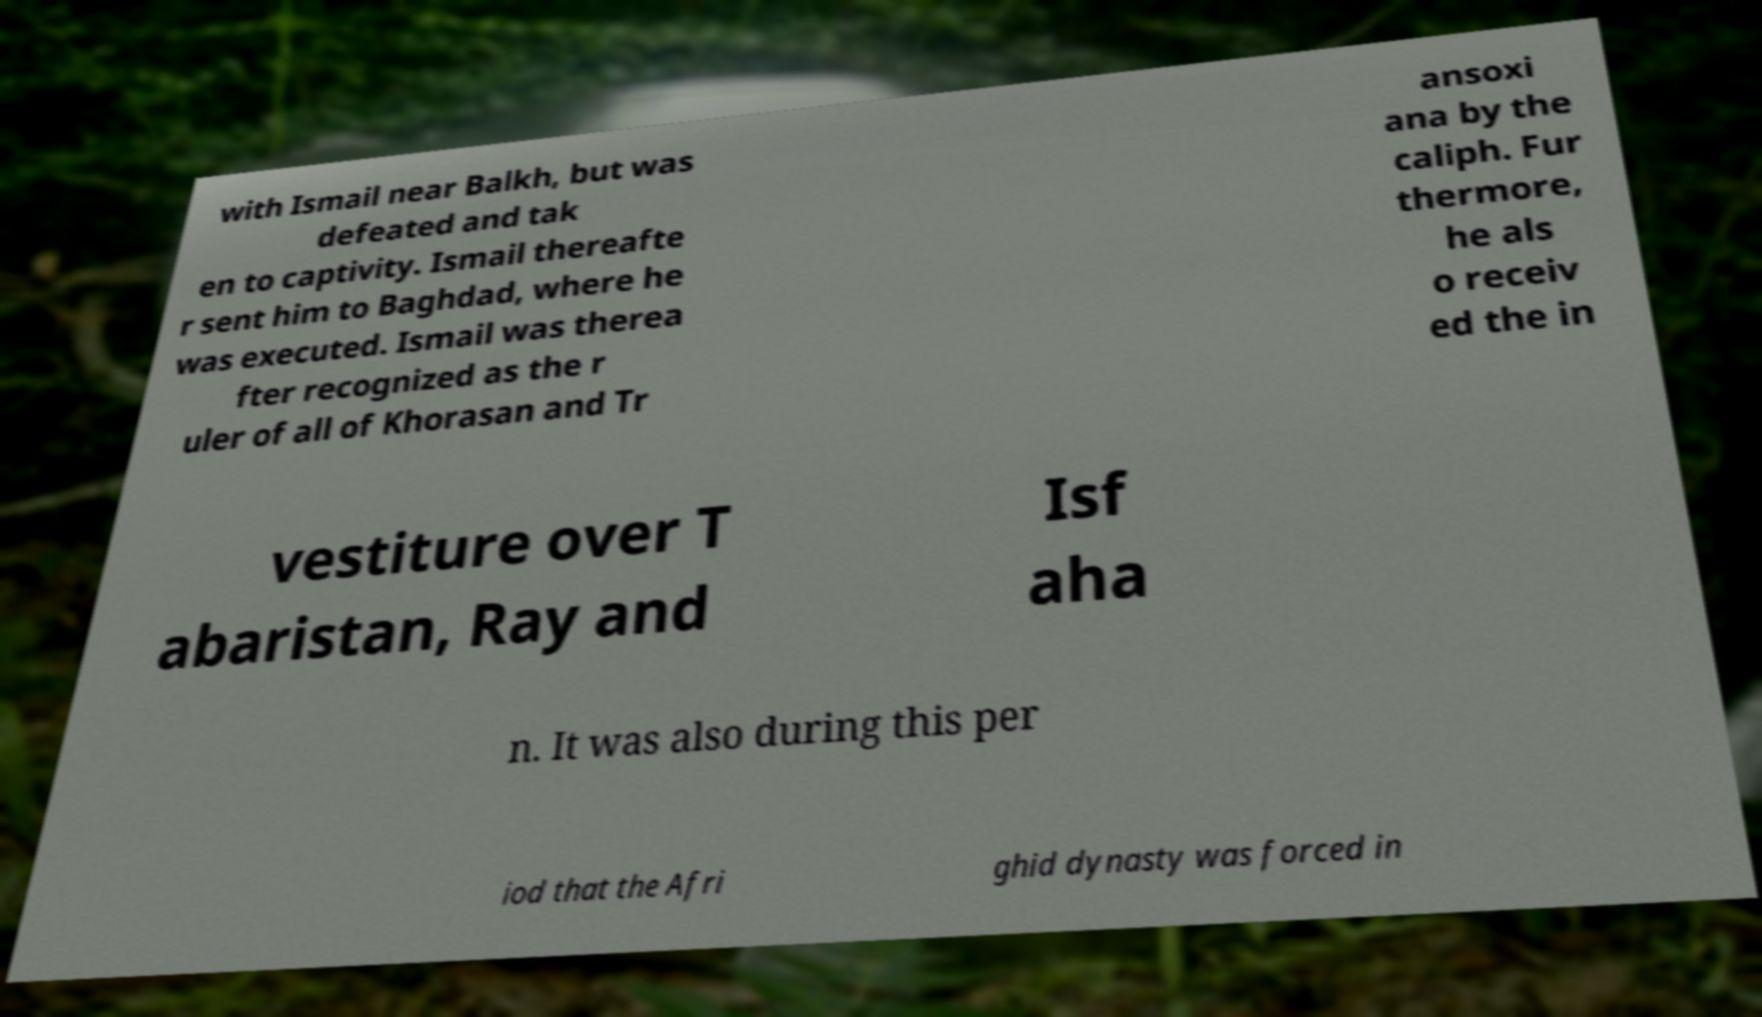Could you assist in decoding the text presented in this image and type it out clearly? with Ismail near Balkh, but was defeated and tak en to captivity. Ismail thereafte r sent him to Baghdad, where he was executed. Ismail was therea fter recognized as the r uler of all of Khorasan and Tr ansoxi ana by the caliph. Fur thermore, he als o receiv ed the in vestiture over T abaristan, Ray and Isf aha n. It was also during this per iod that the Afri ghid dynasty was forced in 